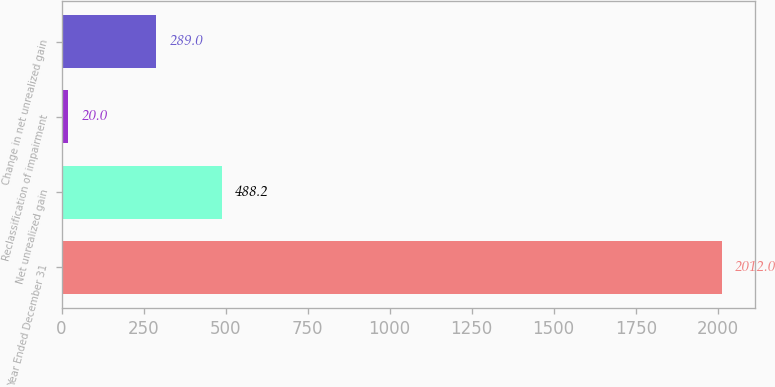Convert chart. <chart><loc_0><loc_0><loc_500><loc_500><bar_chart><fcel>Year Ended December 31<fcel>Net unrealized gain<fcel>Reclassification of impairment<fcel>Change in net unrealized gain<nl><fcel>2012<fcel>488.2<fcel>20<fcel>289<nl></chart> 